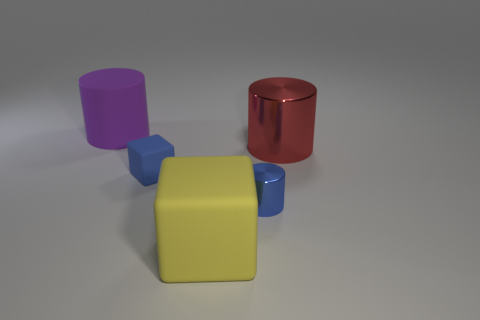Is the material of the blue thing that is behind the blue metallic cylinder the same as the purple cylinder?
Provide a succinct answer. Yes. What shape is the small matte thing?
Provide a succinct answer. Cube. What number of yellow objects are either small matte blocks or blocks?
Provide a succinct answer. 1. What number of other objects are the same material as the small block?
Your response must be concise. 2. There is a small blue thing that is on the right side of the yellow object; is it the same shape as the red metallic thing?
Make the answer very short. Yes. Is there a big red metallic thing?
Keep it short and to the point. Yes. Is there anything else that has the same shape as the large yellow matte object?
Make the answer very short. Yes. Is the number of small metallic cylinders that are right of the yellow cube greater than the number of cyan rubber balls?
Your answer should be compact. Yes. Are there any metal cylinders in front of the tiny rubber block?
Your answer should be very brief. Yes. Does the red shiny cylinder have the same size as the purple object?
Your response must be concise. Yes. 